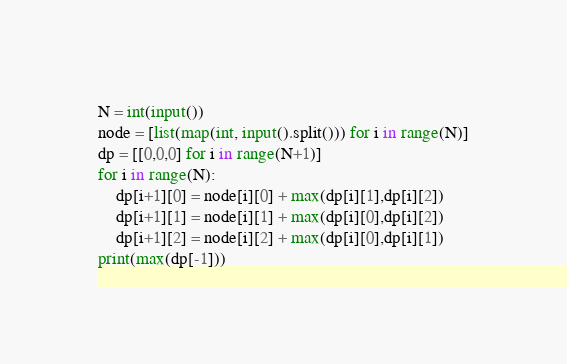<code> <loc_0><loc_0><loc_500><loc_500><_Python_>N = int(input())
node = [list(map(int, input().split())) for i in range(N)]
dp = [[0,0,0] for i in range(N+1)]
for i in range(N):
    dp[i+1][0] = node[i][0] + max(dp[i][1],dp[i][2])
    dp[i+1][1] = node[i][1] + max(dp[i][0],dp[i][2])
    dp[i+1][2] = node[i][2] + max(dp[i][0],dp[i][1])
print(max(dp[-1]))</code> 